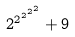<formula> <loc_0><loc_0><loc_500><loc_500>2 ^ { 2 ^ { 2 ^ { 2 ^ { 2 } } } } + 9</formula> 